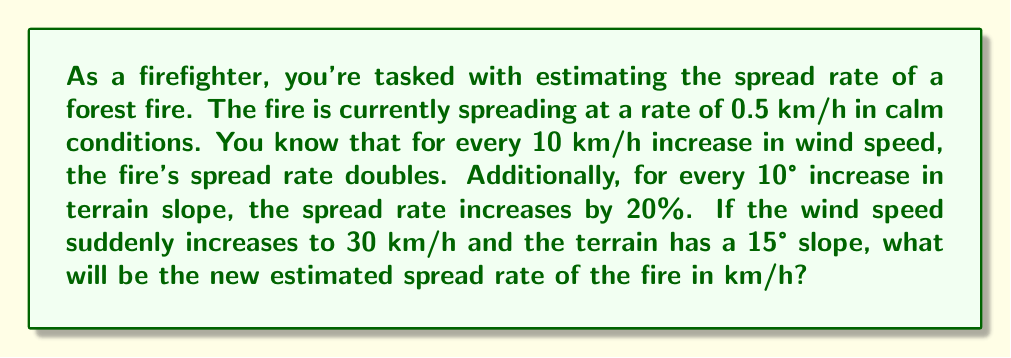Show me your answer to this math problem. Let's approach this problem step-by-step:

1) First, let's calculate the effect of wind speed:
   - The base spread rate is 0.5 km/h
   - For every 10 km/h of wind speed, the rate doubles
   - The wind speed is 30 km/h, which means the rate will double 3 times
   
   Let's express this mathematically:
   $$\text{Wind effect} = 0.5 \times 2^3 = 0.5 \times 8 = 4 \text{ km/h}$$

2) Now, let's calculate the effect of terrain slope:
   - For every 10° increase in slope, the rate increases by 20%
   - The slope is 15°, which means we need to increase by 30%
   
   Let's express this as:
   $$\text{Slope effect} = 1 + (15 \div 10) \times 0.2 = 1 + 0.3 = 1.3$$

3) To get the final spread rate, we multiply the wind effect by the slope effect:

   $$\text{Final spread rate} = 4 \times 1.3 = 5.2 \text{ km/h}$$

Thus, the new estimated spread rate of the fire is 5.2 km/h.
Answer: 5.2 km/h 